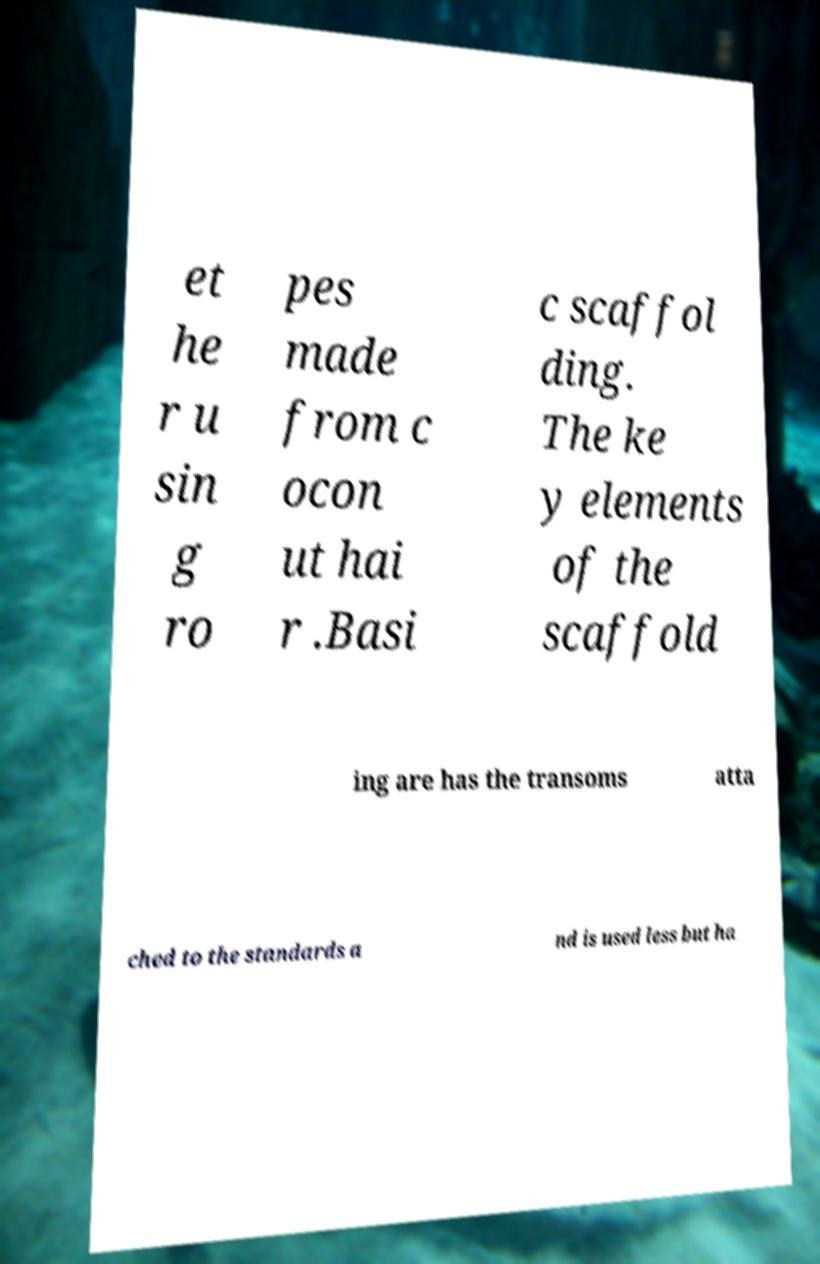Could you extract and type out the text from this image? et he r u sin g ro pes made from c ocon ut hai r .Basi c scaffol ding. The ke y elements of the scaffold ing are has the transoms atta ched to the standards a nd is used less but ha 